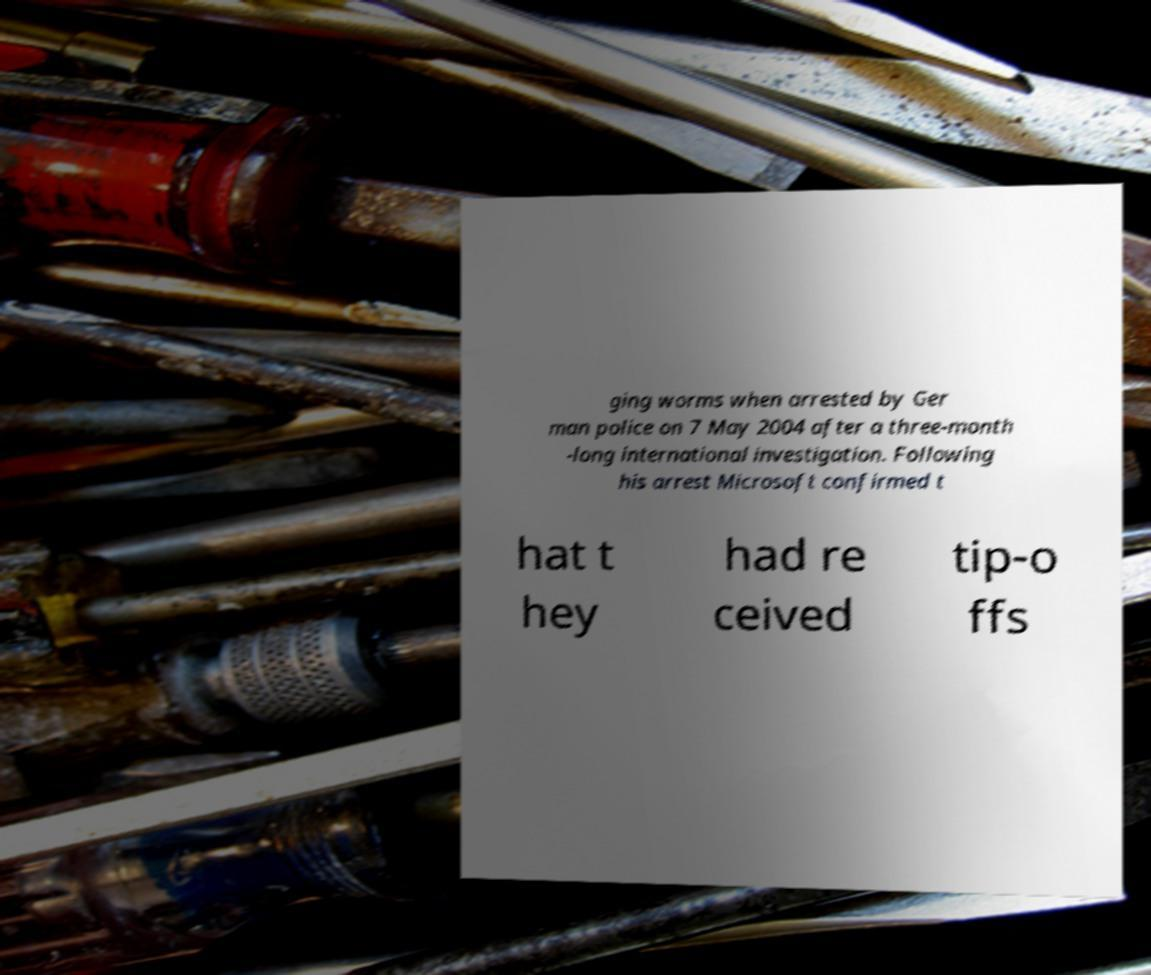Could you assist in decoding the text presented in this image and type it out clearly? ging worms when arrested by Ger man police on 7 May 2004 after a three-month -long international investigation. Following his arrest Microsoft confirmed t hat t hey had re ceived tip-o ffs 